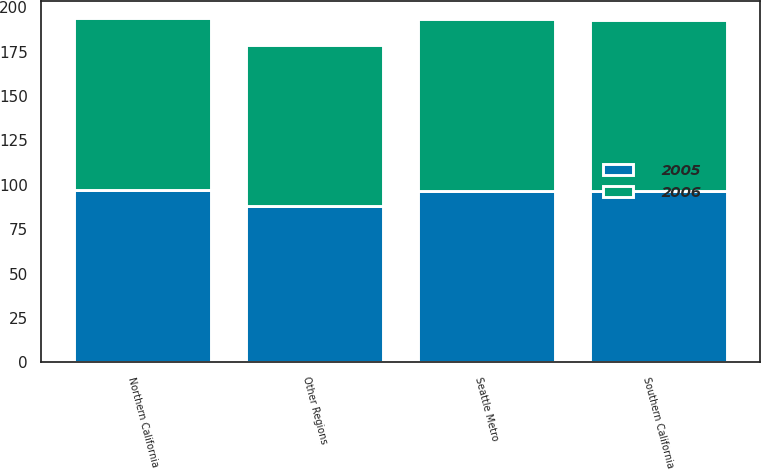Convert chart. <chart><loc_0><loc_0><loc_500><loc_500><stacked_bar_chart><ecel><fcel>Southern California<fcel>Northern California<fcel>Seattle Metro<fcel>Other Regions<nl><fcel>2006<fcel>96.3<fcel>96.7<fcel>96.9<fcel>90.6<nl><fcel>2005<fcel>96.5<fcel>97.1<fcel>96.7<fcel>88.1<nl></chart> 